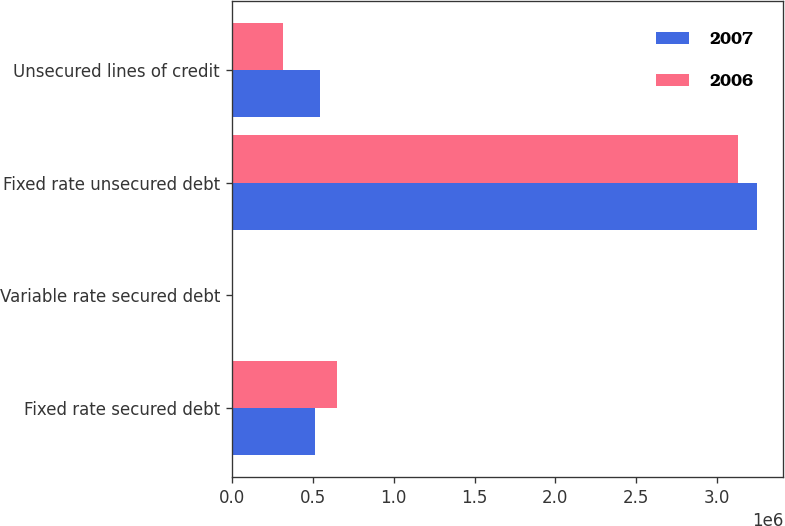Convert chart to OTSL. <chart><loc_0><loc_0><loc_500><loc_500><stacked_bar_chart><ecel><fcel>Fixed rate secured debt<fcel>Variable rate secured debt<fcel>Fixed rate unsecured debt<fcel>Unsecured lines of credit<nl><fcel>2007<fcel>515423<fcel>8970<fcel>3.246e+06<fcel>546067<nl><fcel>2006<fcel>652886<fcel>9615<fcel>3.12516e+06<fcel>317000<nl></chart> 